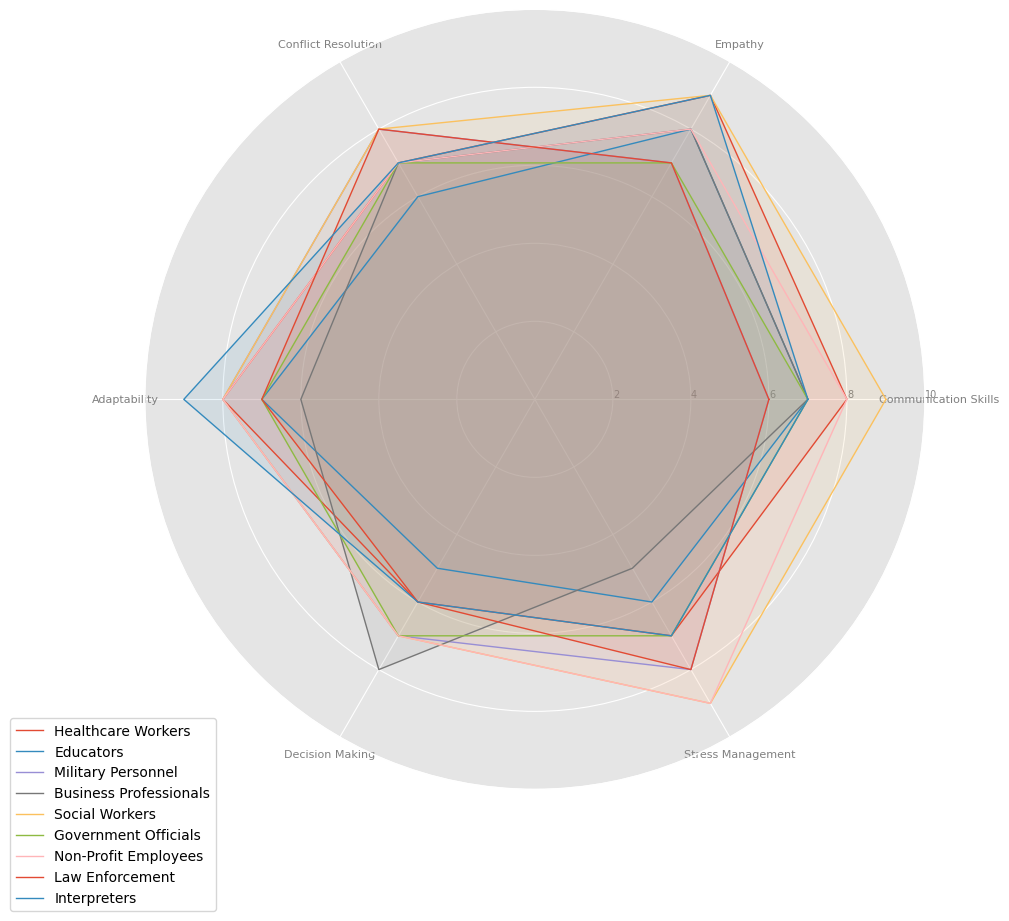What's the profession with the highest average score across all categories? To find the highest average score, calculate the mean score for each profession by summing their scores across all categories and dividing by the number of categories. Social Workers have scores: (9+9+8+8+7+9)/6 = 8.33, which is the highest.
Answer: Social Workers Which profession scores the highest in Empathy? By looking at the Empathy category, we see that Healthcare Workers, Social Workers, and Interpreters all score 9, the highest.
Answer: Healthcare Workers, Social Workers, Interpreters Between Military Personnel and Business Professionals, who scores higher in Decision Making? Comparing the Decision Making scores of Military Personnel (7) and Business Professionals (8), Business Professionals have a higher score.
Answer: Business Professionals What is the combined score of Adaptability and Stress Management for Law Enforcement? Law Enforcement scores 7 in Adaptability and 8 in Stress Management. Summing these values: 7 + 8 = 15.
Answer: 15 Rank the professions in the Communication Skills category from highest to lowest. To rank, compare the Communication Skills scores: Healthcare Workers (8), Educators (7), Military Personnel (6), Business Professionals (7), Social Workers (9), Government Officials (7), Non-Profit Employees (8), Law Enforcement (6), Interpreters (7). Thus the order is: Social Workers, Healthcare Workers / Non-Profit Employees / Interpreters / Educators / Business Professionals / Government Officials, Military Personnel / Law Enforcement.
Answer: Social Workers > Healthcare Workers / Non-Profit Employees > Interpreters / Educators / Business Professionals / Government Officials > Military Personnel / Law Enforcement Which profession has the most balanced scores across all categories? A balanced score means similar values across categories. Government Officials have the most balanced score with all categories being 7.
Answer: Government Officials How many professions score 8 or higher in Conflict Resolution? Checking the Conflict Resolution scores: Healthcare Workers (7), Educators (6), Military Personnel (8), Business Professionals (7), Social Workers (8), Government Officials (7), Non-Profit Employees (7), Law Enforcement (8), Interpreters (7). Four professions score 8 or higher: Military Personnel, Social Workers, Law Enforcement.
Answer: 3 What's the difference between the highest and lowest scores in Adaptability? The highest Adaptability score is 9 (Interpreters), and the lowest is 6 (Business Professionals). The difference is: 9 - 6 = 3.
Answer: 3 